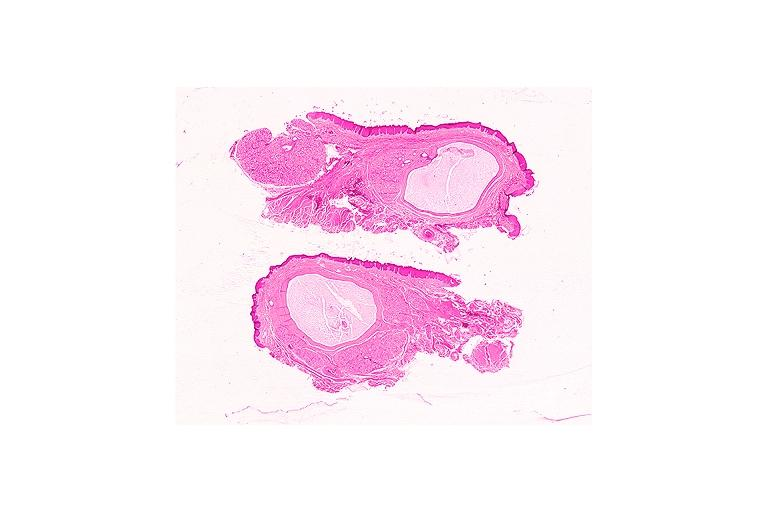does this image show mucocele?
Answer the question using a single word or phrase. Yes 